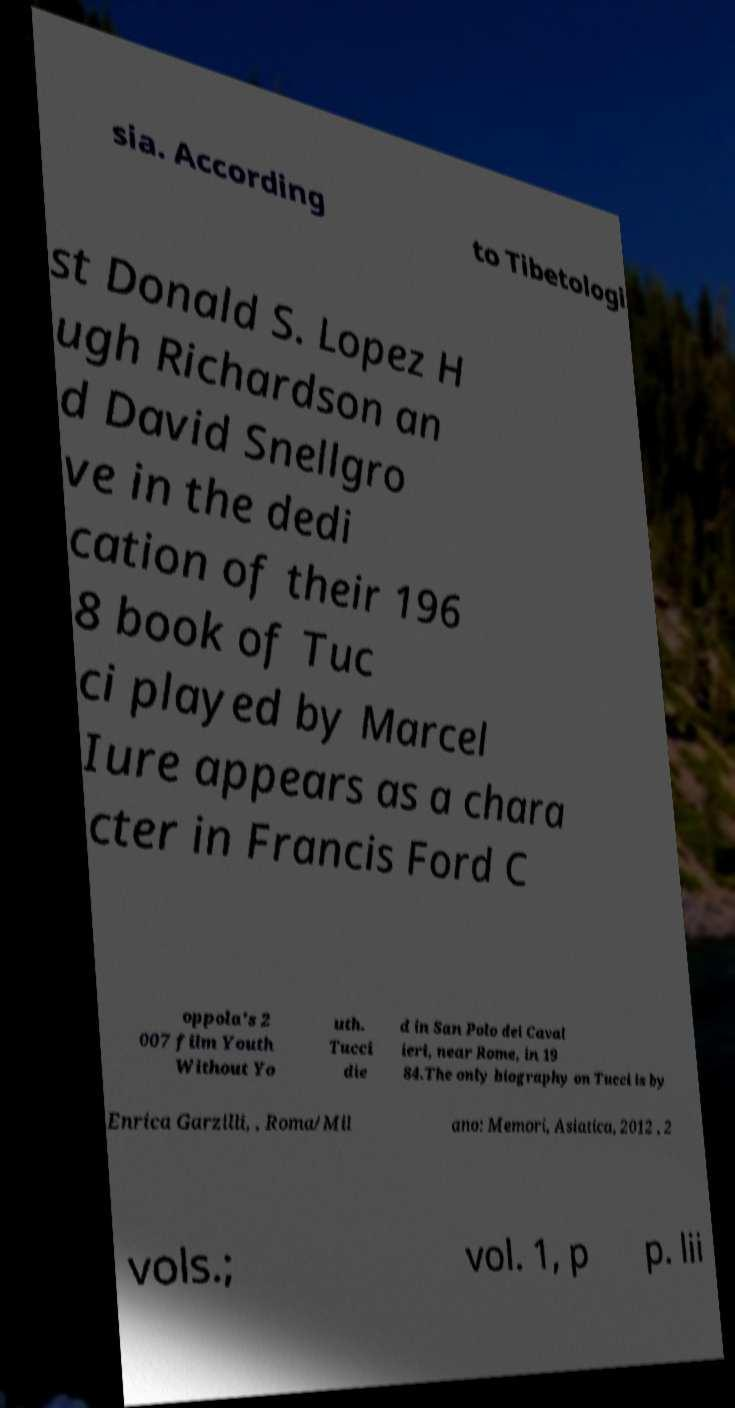There's text embedded in this image that I need extracted. Can you transcribe it verbatim? sia. According to Tibetologi st Donald S. Lopez H ugh Richardson an d David Snellgro ve in the dedi cation of their 196 8 book of Tuc ci played by Marcel Iure appears as a chara cter in Francis Ford C oppola's 2 007 film Youth Without Yo uth. Tucci die d in San Polo dei Caval ieri, near Rome, in 19 84.The only biography on Tucci is by Enrica Garzilli, , Roma/Mil ano: Memori, Asiatica, 2012 , 2 vols.; vol. 1, p p. lii 